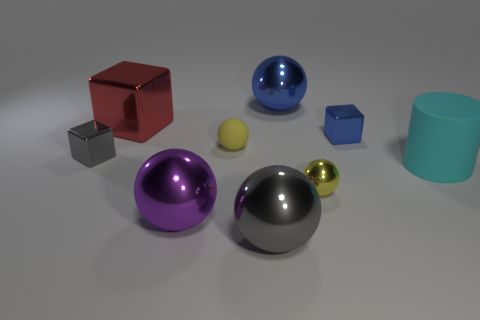Subtract all gray cylinders. Subtract all purple blocks. How many cylinders are left? 1 Add 1 large red matte blocks. How many objects exist? 10 Subtract all cylinders. How many objects are left? 8 Subtract 1 blue spheres. How many objects are left? 8 Subtract all tiny gray metallic things. Subtract all gray things. How many objects are left? 6 Add 8 small blue shiny cubes. How many small blue shiny cubes are left? 9 Add 9 tiny rubber spheres. How many tiny rubber spheres exist? 10 